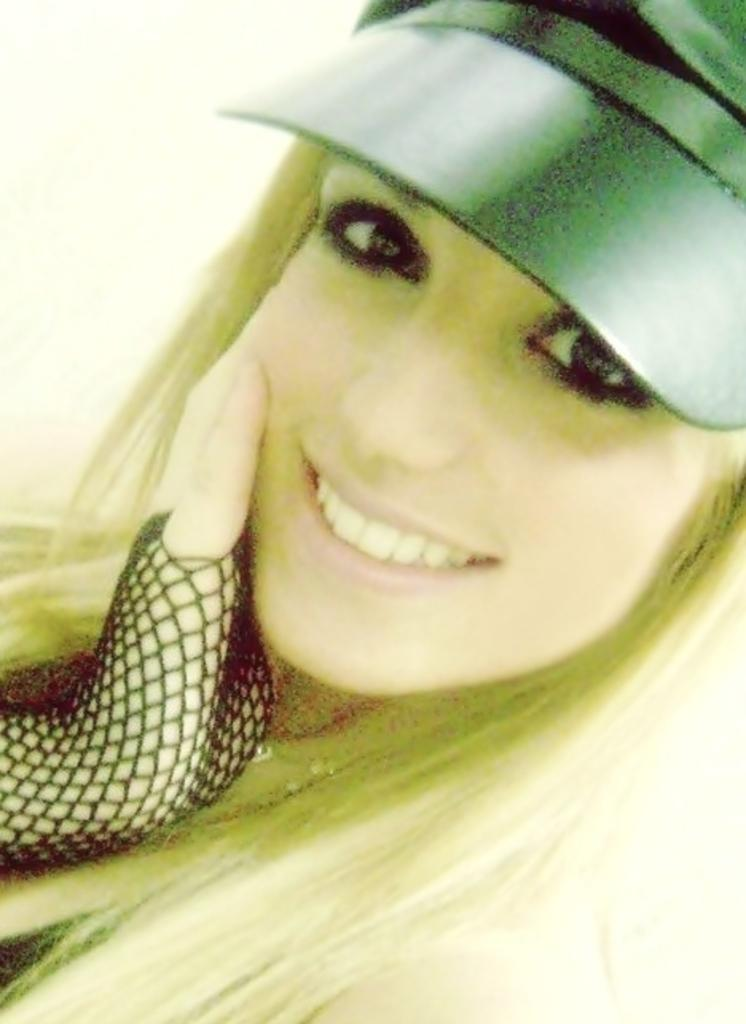What is present in the image? There is a woman in the image. What is the woman doing in the image? The woman is smiling in the image. What type of clothing accessory is the woman wearing? The woman is wearing a cap in the image. What type of bead is the woman holding in the image? There is no bead present in the image. What type of wood is the woman standing on in the image? There is no wood present in the image, and the woman is not standing on any surface. What type of parcel is the woman carrying in the image? There is no parcel present in the image. 